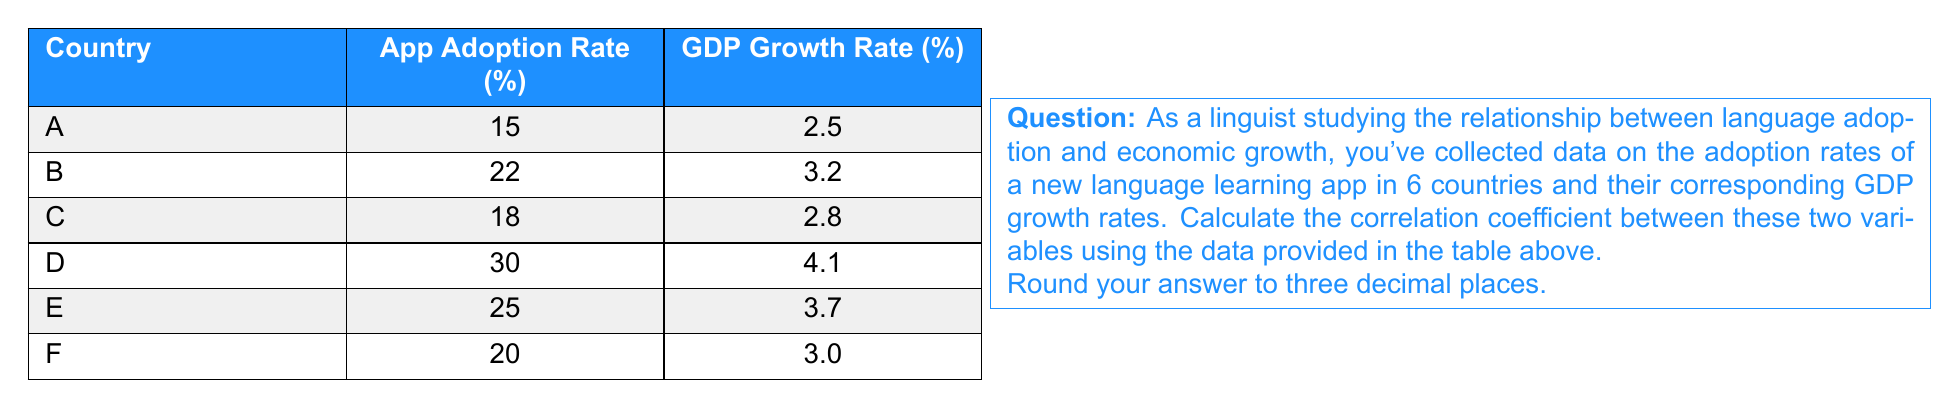Help me with this question. To calculate the correlation coefficient, we'll use the Pearson correlation formula:

$$ r = \frac{\sum_{i=1}^{n} (x_i - \bar{x})(y_i - \bar{y})}{\sqrt{\sum_{i=1}^{n} (x_i - \bar{x})^2 \sum_{i=1}^{n} (y_i - \bar{y})^2}} $$

Where:
$x_i$ = App Adoption Rate
$y_i$ = GDP Growth Rate
$\bar{x}$ = Mean of App Adoption Rates
$\bar{y}$ = Mean of GDP Growth Rates
$n$ = Number of countries (6)

Step 1: Calculate means
$\bar{x} = \frac{15 + 22 + 18 + 30 + 25 + 20}{6} = 21.67$
$\bar{y} = \frac{2.5 + 3.2 + 2.8 + 4.1 + 3.7 + 3.0}{6} = 3.22$

Step 2: Calculate $(x_i - \bar{x})$, $(y_i - \bar{y})$, $(x_i - \bar{x})^2$, $(y_i - \bar{y})^2$, and $(x_i - \bar{x})(y_i - \bar{y})$

Country | $(x_i - \bar{x})$ | $(y_i - \bar{y})$ | $(x_i - \bar{x})^2$ | $(y_i - \bar{y})^2$ | $(x_i - \bar{x})(y_i - \bar{y})$
--------|-------------------|-------------------|---------------------|---------------------|-------------------------------
A       | -6.67             | -0.72             | 44.49               | 0.52                | 4.80
B       | 0.33              | -0.02             | 0.11                | 0.00                | -0.01
C       | -3.67             | -0.42             | 13.47               | 0.18                | 1.54
D       | 8.33              | 0.88              | 69.39               | 0.77                | 7.33
E       | 3.33              | 0.48              | 11.09               | 0.23                | 1.60
F       | -1.67             | -0.22             | 2.79                | 0.05                | 0.37

Step 3: Sum the columns
$\sum (x_i - \bar{x})^2 = 141.34$
$\sum (y_i - \bar{y})^2 = 1.75$
$\sum (x_i - \bar{x})(y_i - \bar{y}) = 15.63$

Step 4: Apply the formula
$$ r = \frac{15.63}{\sqrt{141.34 \times 1.75}} = \frac{15.63}{15.73} = 0.994 $$

Rounded to three decimal places: 0.994
Answer: 0.994 